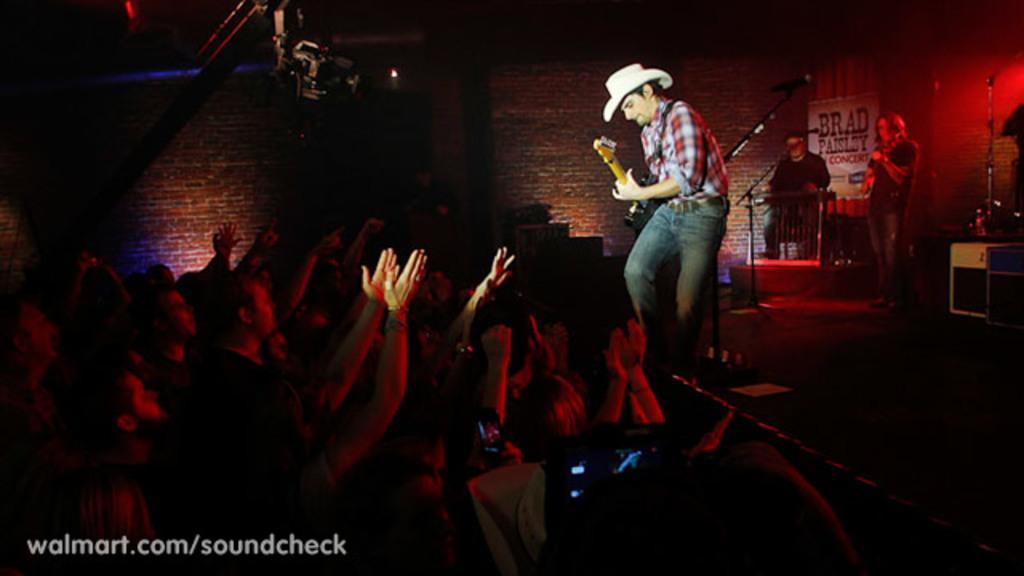Can you describe this image briefly? There is a group of a people. The persons are playing a musical instruments. Everyone listening to him. We can see in the background red wall bricks. 